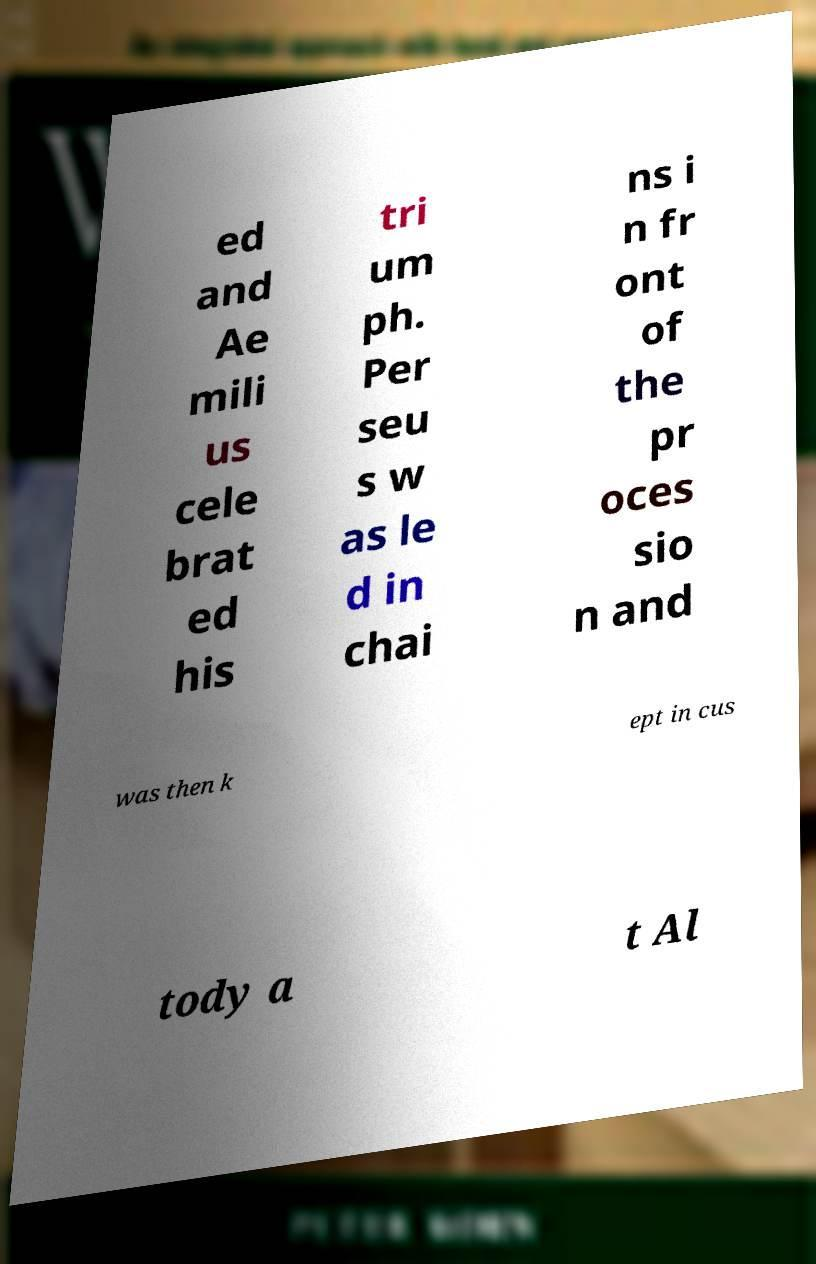For documentation purposes, I need the text within this image transcribed. Could you provide that? ed and Ae mili us cele brat ed his tri um ph. Per seu s w as le d in chai ns i n fr ont of the pr oces sio n and was then k ept in cus tody a t Al 